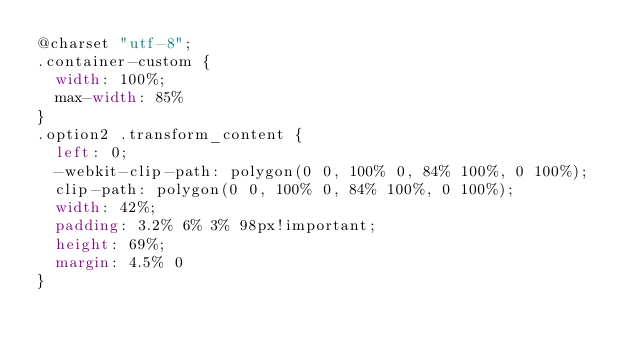<code> <loc_0><loc_0><loc_500><loc_500><_CSS_>@charset "utf-8";
.container-custom {
	width: 100%;
	max-width: 85%
}
.option2 .transform_content {
	left: 0;
	-webkit-clip-path: polygon(0 0, 100% 0, 84% 100%, 0 100%);
	clip-path: polygon(0 0, 100% 0, 84% 100%, 0 100%);
	width: 42%;
	padding: 3.2% 6% 3% 98px!important;
	height: 69%;
	margin: 4.5% 0
}</code> 